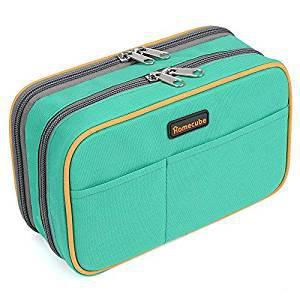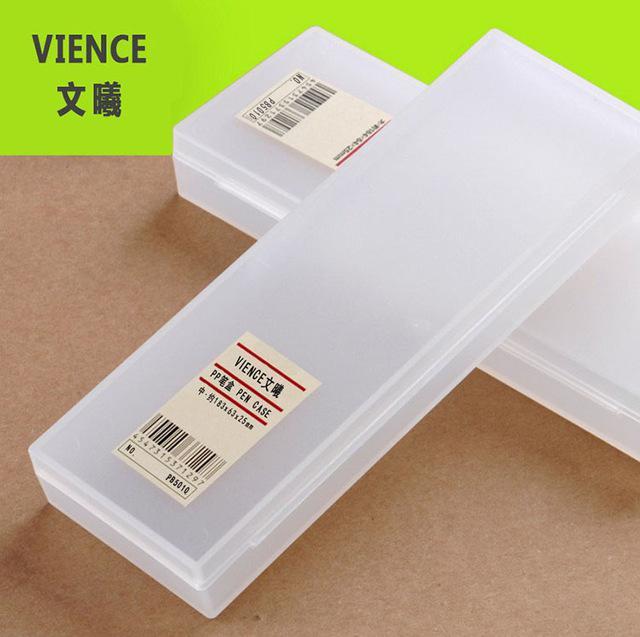The first image is the image on the left, the second image is the image on the right. Analyze the images presented: Is the assertion "The pencil cases are open." valid? Answer yes or no. No. The first image is the image on the left, the second image is the image on the right. Given the left and right images, does the statement "Each image includes an open plastic rectangular case filled with supplies, and at least one of the open cases pictured is greenish." hold true? Answer yes or no. No. 